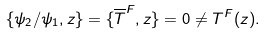Convert formula to latex. <formula><loc_0><loc_0><loc_500><loc_500>\{ \psi _ { 2 } / \psi _ { 1 } , z \} = \{ \overline { T } ^ { F } , z \} = 0 \ne T ^ { F } ( z ) .</formula> 